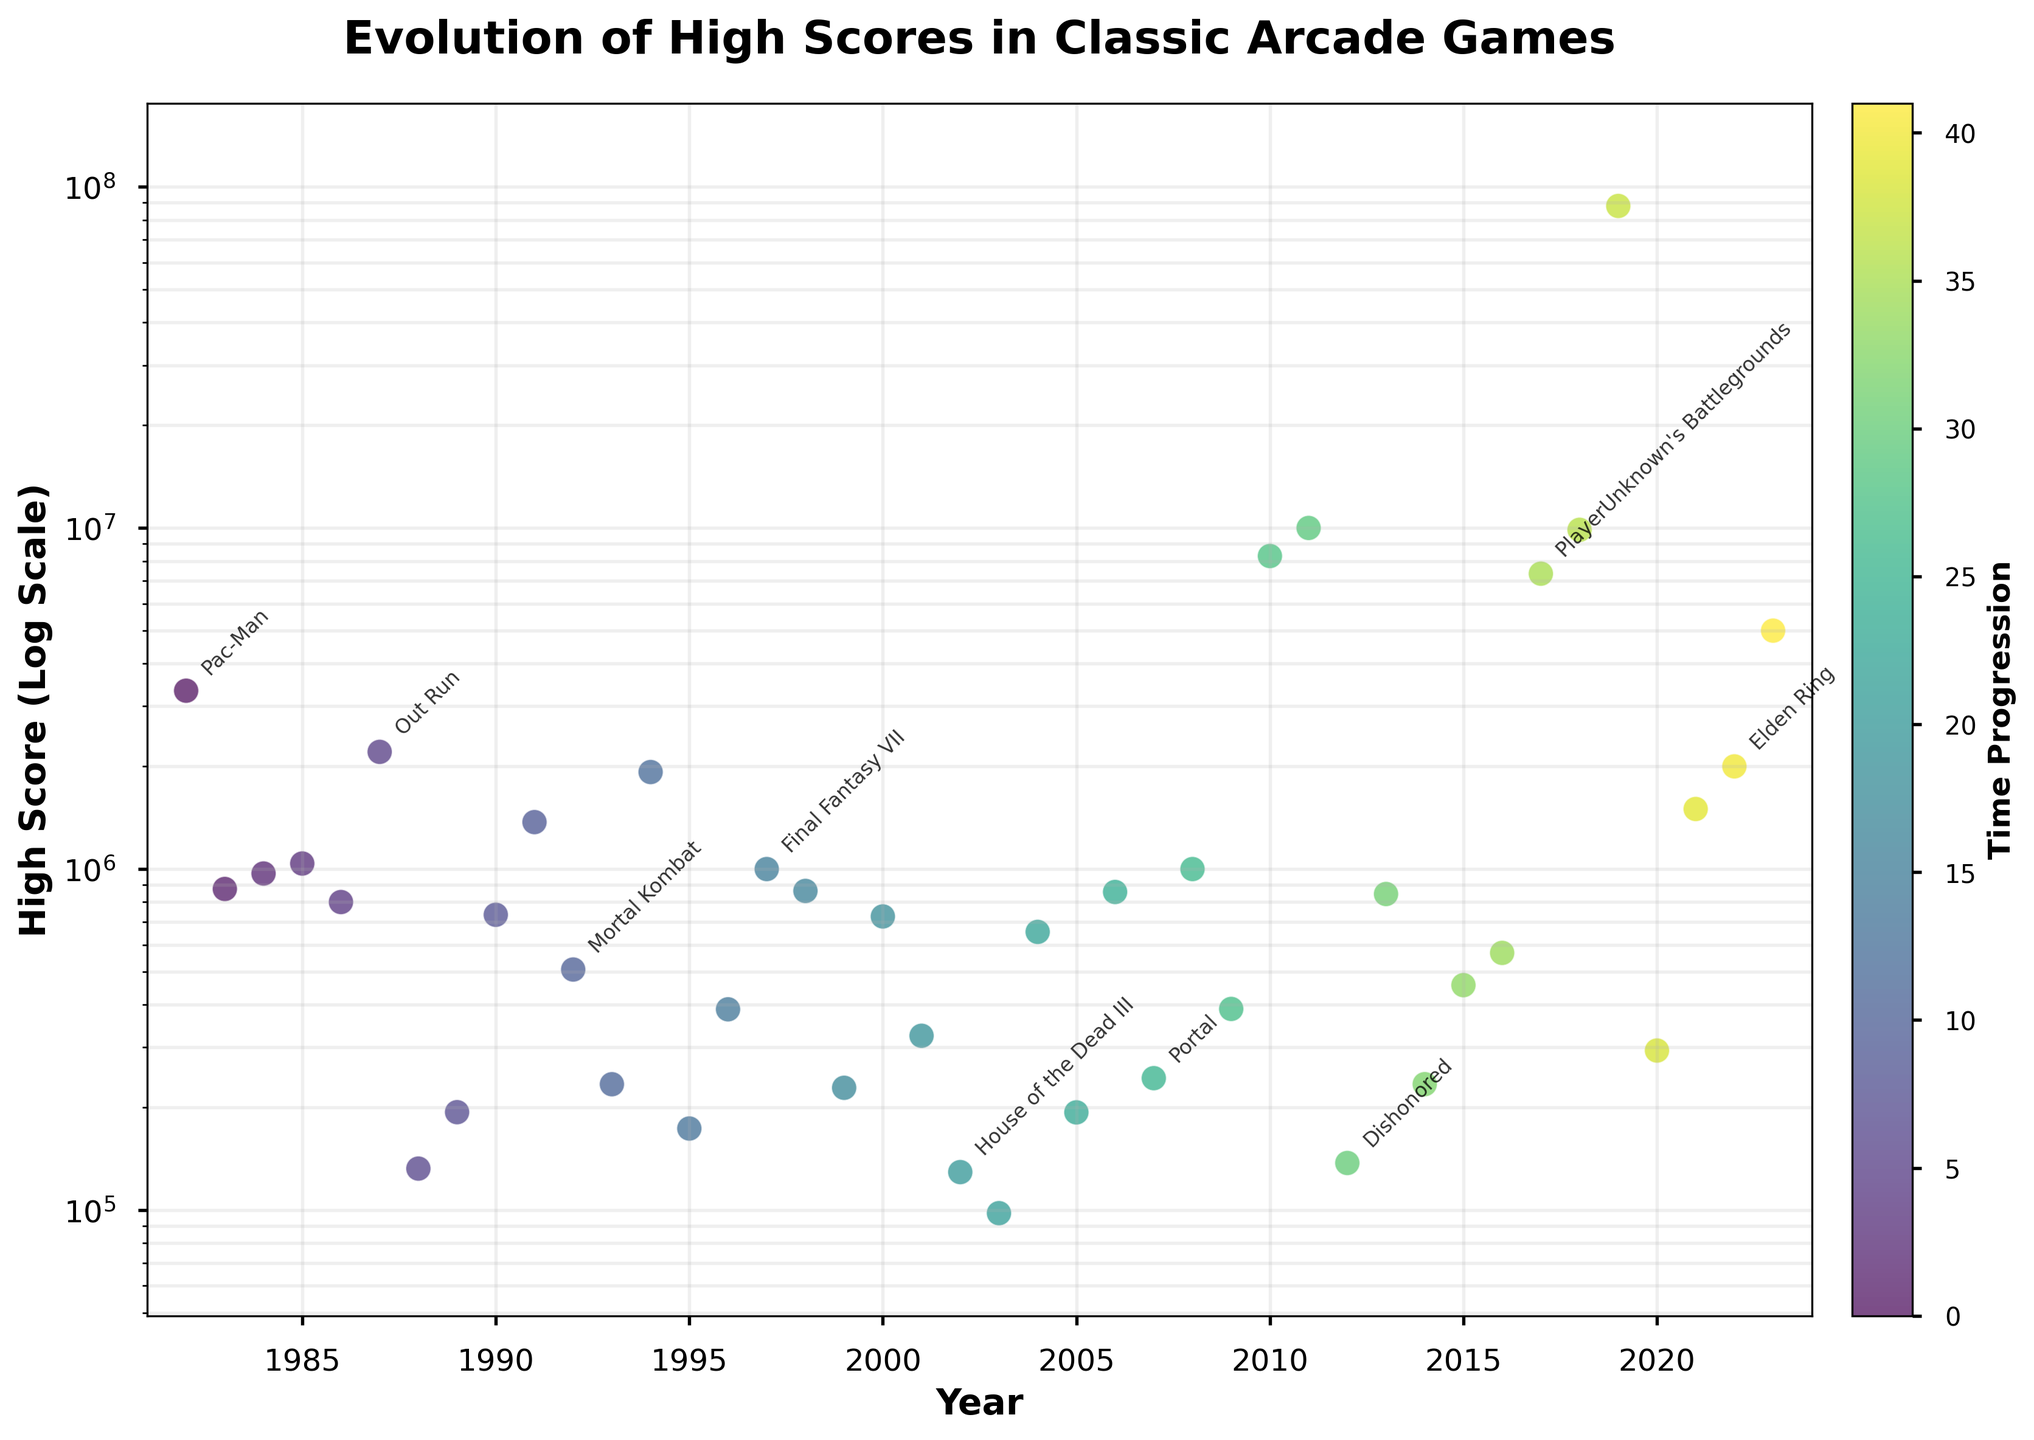what is the title of the plot? The title of the plot is displayed prominently at the top center of the figure and is written in a larger and bold font. The title is "Evolution of High Scores in Classic Arcade Games."
Answer: Evolution of High Scores in Classic Arcade Games How many data points are displayed in the plot? The number of data points can be calculated by counting the number of individual markers or scatter points in the figure. By going through the data, we count 42 points.
Answer: 42 What is the y-axis scale of the plot? The scale of the y-axis is indicated by the label and the appearance of the tick marks. The label "High Score (Log Scale)" indicates that a logarithmic scale is used.
Answer: Logarithmic Which game achieved the highest score and in what year? The game with the highest score can be identified by looking at the peak value on the y-axis. The highest score marking is for "Apex Legends" in 2019, with a score shown at the topmost point just under 100,000,000.
Answer: Apex Legends, 2019 What is the range of years covered in the plot? The range of years can be determined by looking at the x-axis and noting the first and last data points. The plot starts at 1982 and ends at 2023.
Answer: 1982 to 2023 How many games have a high score greater than 1,000,000? To answer this, observe the data points that fall above the 1,000,000 mark on the y-axis. By counting these points, we find that there are 12 games with a high score greater than 1,000,000.
Answer: 12 Which decade saw the highest concentration of high scores above 1,000,000? To identify this, consider the time periods and count how many data points fall above the 1,000,000 mark within each decade. The 1980s appear to have several high scores above 1,000,000, leading to it being the decade with the highest concentration of such scores.
Answer: 1980s Between the 1980s and 2020s, which decade shows a more significant increase in high scores? Comparing the scores in the first decade (1980s) and the last decade (2020s), it’s evident from the y-axis that there is a more significant increase in scores in the 2020s, with scores reaching up to nearly 90,000,000.
Answer: 2020s What is the average high score in the 1990s? Calculate the average by identifying the data points from 1990 to 1999 and summing their high scores, then dividing by the number of games. From the plot, the scores are: 734500, 1372940, 507560, 234000, 1925000, 173520, 388000, 999999, 862800, and 228440. The total is 7521759, and the average is 752175.9.
Answer: 752175.9 